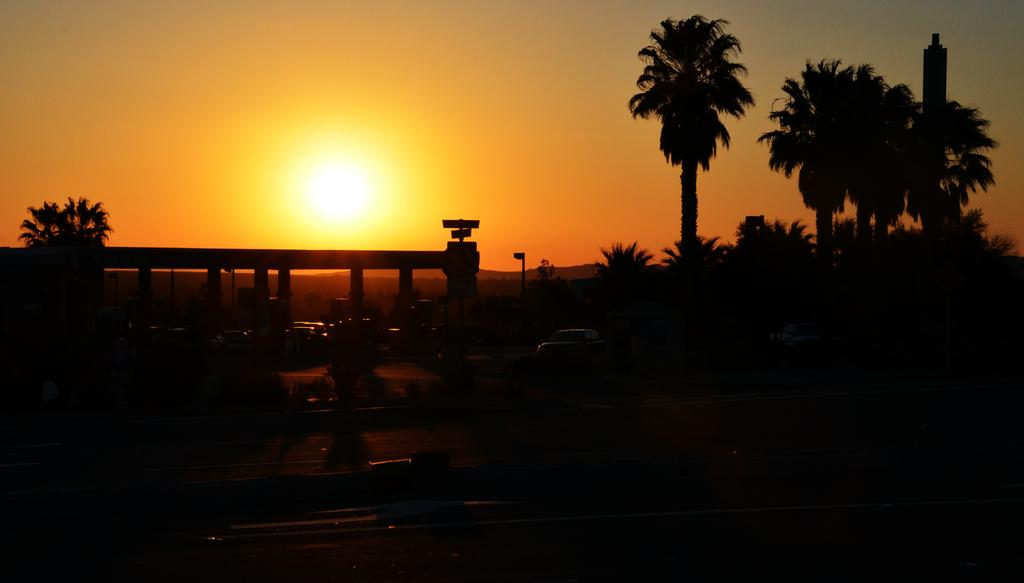What is the overall lighting condition in the image? The image is dark. What can be seen on the ground in the image? There is a road in the image. What types of objects are present on the road? There are vehicles in the image. What type of natural environment is visible in the image? There are trees in the image. What is visible in the background of the image? The sky is visible in the background of the image. Can you describe the celestial body visible in the sky? The sun is visible in the sky. What type of idea is being played with by the selection of trees in the image? There is no idea or selection of trees present in the image; it features a road, vehicles, trees, and a sky with the sun. 